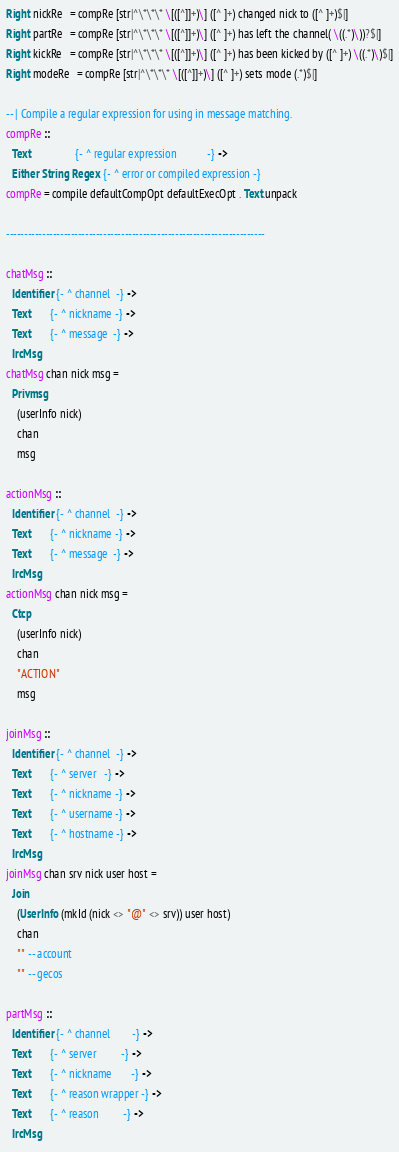<code> <loc_0><loc_0><loc_500><loc_500><_Haskell_>Right nickRe   = compRe [str|^\*\*\* \[([^]]+)\] ([^ ]+) changed nick to ([^ ]+)$|]
Right partRe   = compRe [str|^\*\*\* \[([^]]+)\] ([^ ]+) has left the channel( \((.*)\))?$|]
Right kickRe   = compRe [str|^\*\*\* \[([^]]+)\] ([^ ]+) has been kicked by ([^ ]+) \((.*)\)$|]
Right modeRe   = compRe [str|^\*\*\* \[([^]]+)\] ([^ ]+) sets mode (.*)$|]

-- | Compile a regular expression for using in message matching.
compRe ::
  Text                {- ^ regular expression           -} ->
  Either String Regex {- ^ error or compiled expression -}
compRe = compile defaultCompOpt defaultExecOpt . Text.unpack

------------------------------------------------------------------------

chatMsg ::
  Identifier {- ^ channel  -} ->
  Text       {- ^ nickname -} ->
  Text       {- ^ message  -} ->
  IrcMsg
chatMsg chan nick msg =
  Privmsg
    (userInfo nick)
    chan
    msg

actionMsg ::
  Identifier {- ^ channel  -} ->
  Text       {- ^ nickname -} ->
  Text       {- ^ message  -} ->
  IrcMsg
actionMsg chan nick msg =
  Ctcp
    (userInfo nick)
    chan
    "ACTION"
    msg

joinMsg ::
  Identifier {- ^ channel  -} ->
  Text       {- ^ server   -} ->
  Text       {- ^ nickname -} ->
  Text       {- ^ username -} ->
  Text       {- ^ hostname -} ->
  IrcMsg
joinMsg chan srv nick user host =
  Join
    (UserInfo (mkId (nick <> "@" <> srv)) user host)
    chan
    "" -- account
    "" -- gecos

partMsg ::
  Identifier {- ^ channel        -} ->
  Text       {- ^ server         -} ->
  Text       {- ^ nickname       -} ->
  Text       {- ^ reason wrapper -} ->
  Text       {- ^ reason         -} ->
  IrcMsg</code> 